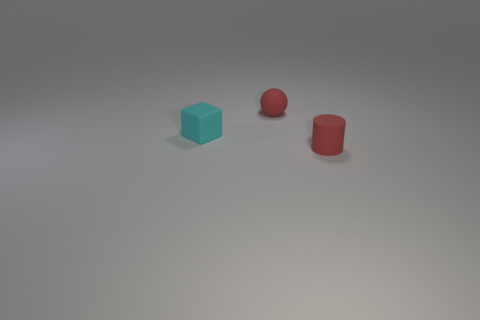What number of tiny objects are the same color as the sphere?
Provide a short and direct response. 1. Is there anything else that has the same shape as the small cyan matte object?
Your answer should be very brief. No. Does the object left of the small red rubber ball have the same material as the small sphere?
Make the answer very short. Yes. There is a thing that is to the right of the tiny matte block and behind the small rubber cylinder; what is its shape?
Keep it short and to the point. Sphere. There is a red matte object that is behind the small rubber cylinder; are there any small red matte objects that are on the right side of it?
Your answer should be very brief. Yes. How many other objects are the same material as the small red sphere?
Provide a short and direct response. 2. Is the shape of the tiny red object that is in front of the cyan object the same as the small red rubber thing behind the tiny red cylinder?
Provide a short and direct response. No. Do the tiny red cylinder and the cyan cube have the same material?
Ensure brevity in your answer.  Yes. There is a red rubber object that is behind the small thing to the right of the tiny red matte object behind the matte cylinder; how big is it?
Your response must be concise. Small. How many other objects are there of the same color as the tiny matte cube?
Ensure brevity in your answer.  0. 